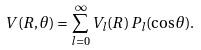<formula> <loc_0><loc_0><loc_500><loc_500>V ( R , \theta ) = \sum _ { l = 0 } ^ { \infty } V _ { l } ( R ) \, P _ { l } ( \cos \theta ) .</formula> 